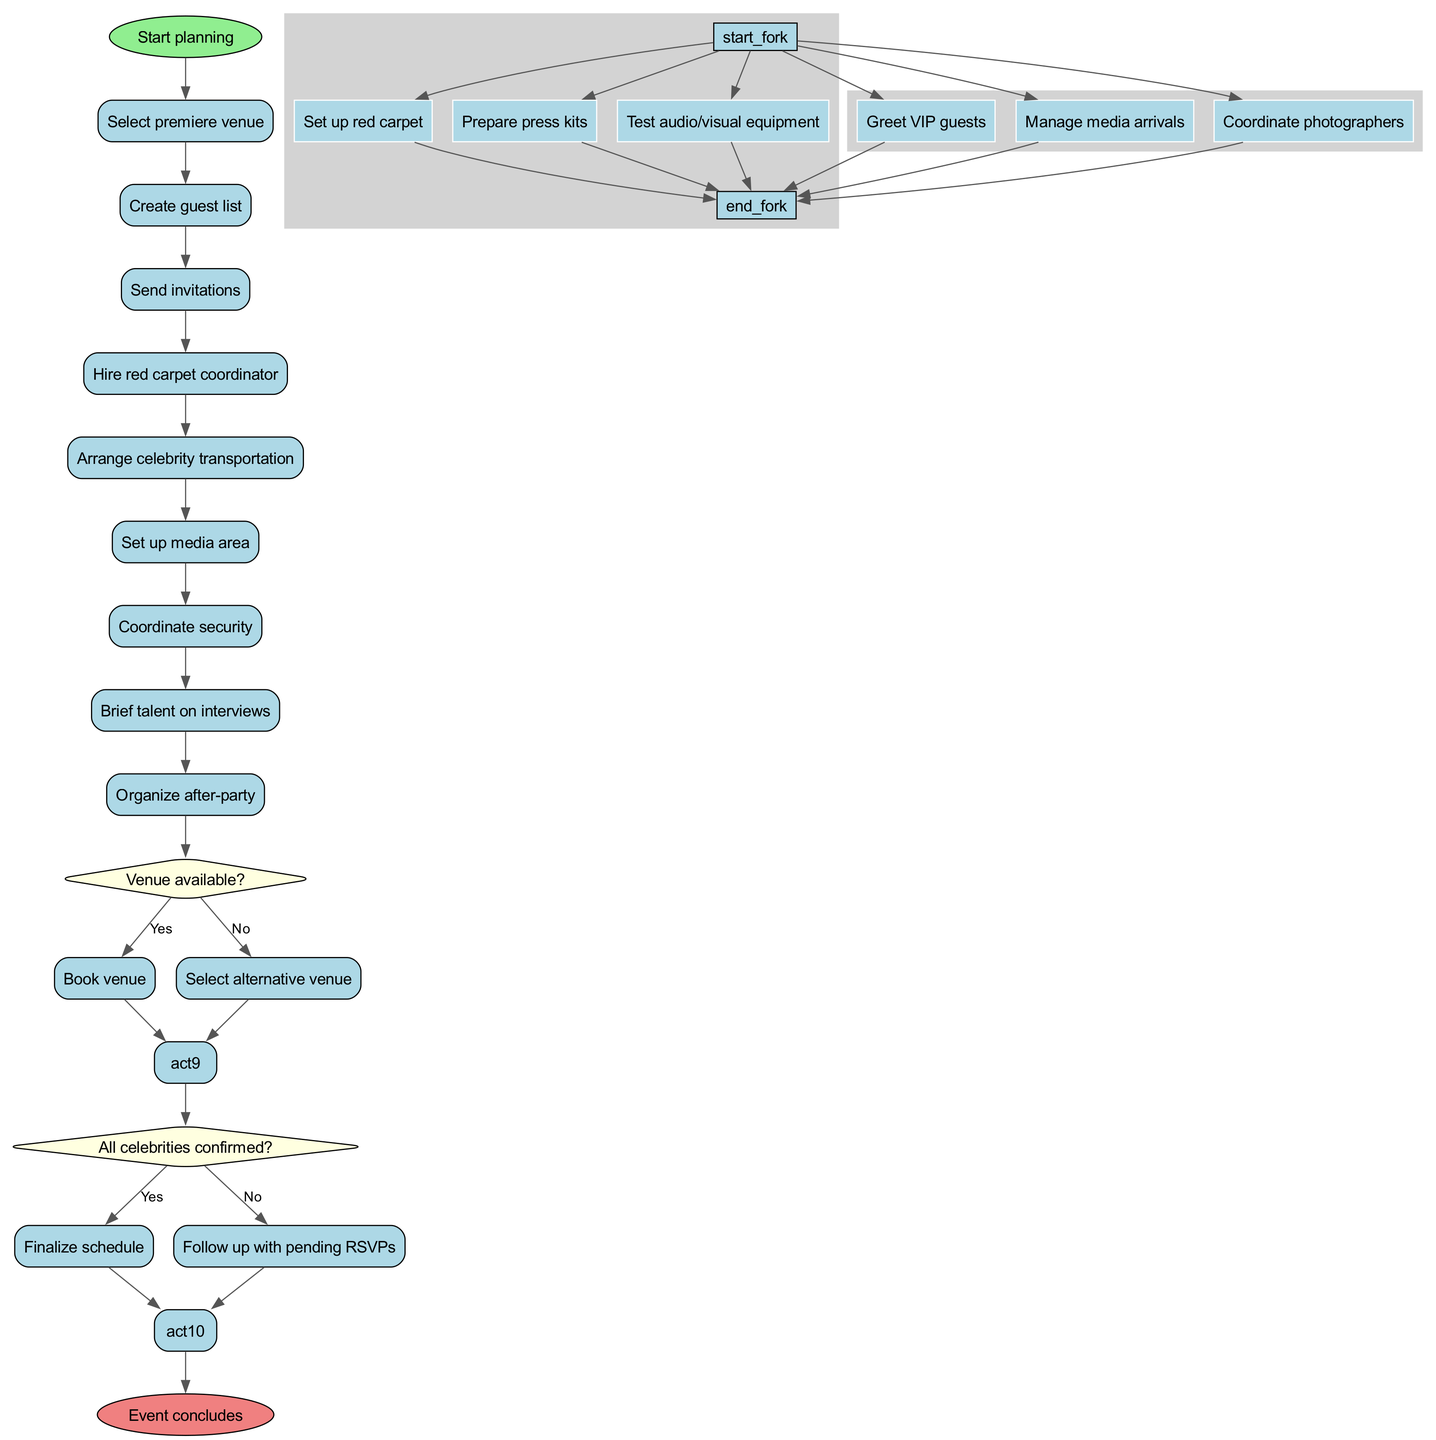What is the initial activity in the diagram? The diagram starts with the node labeled "Start planning," which indicates the beginning of the event organization process.
Answer: Start planning How many final activities are there? There is only one final node in the diagram, labeled "Event concludes." This signifies the end of the process following all planned activities.
Answer: 1 What activity follows the decision "All celebrities confirmed?" if the answer is 'Yes'? If the decision regarding celebrity confirmations is answered 'Yes,' the next activity is to "Finalize schedule." This indicates that the process will proceed to solidify the event timetable.
Answer: Finalize schedule Which activities are executed in parallel after hiring the red carpet coordinator? The diagram indicates that after hiring the red carpet coordinator, three activities are executed in parallel: "Set up red carpet," "Prepare press kits," and "Test audio/visual equipment." These activities can occur simultaneously.
Answer: Set up red carpet, Prepare press kits, Test audio/visual equipment What is the output of the decision "Venue available?" if the answer is 'No'? If the answer to the venue availability decision is 'No,' the immediate output is "Select alternative venue." This means the planning would require choosing a different venue option.
Answer: Select alternative venue What’s the relationship between "Arrange celebrity transportation" and the decision about celebrity confirmations? The activity "Arrange celebrity transportation" occurs before the decision regarding whether all celebrities are confirmed, as it is part of the planned sequence before checking confirmations.
Answer: Precedes the decision Which activity comes last before the event concludes? The last activity before reaching the "Event concludes" node is "Organize after-party." This signifies that everything is wrapped up leading into the conclusion of the event.
Answer: Organize after-party What decision follows the activity "Send invitations"? After "Send invitations," the decision about whether all celebrities are confirmed follows in the sequence of the activities. It assesses the responses from the invitations sent out.
Answer: All celebrities confirmed? 